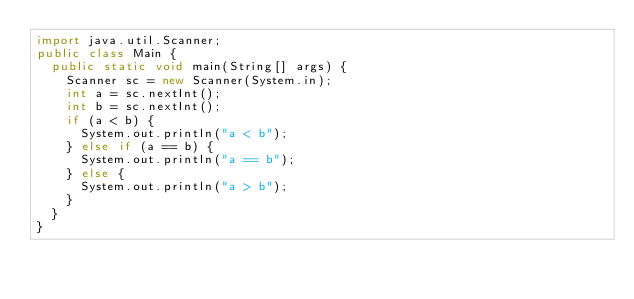<code> <loc_0><loc_0><loc_500><loc_500><_Java_>import java.util.Scanner;
public class Main {
  public static void main(String[] args) {
    Scanner sc = new Scanner(System.in);
    int a = sc.nextInt();
    int b = sc.nextInt();
    if (a < b) {
      System.out.println("a < b");
    } else if (a == b) {
      System.out.println("a == b");
    } else {
      System.out.println("a > b");
    }
  }
}

</code> 